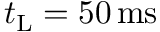Convert formula to latex. <formula><loc_0><loc_0><loc_500><loc_500>t _ { L } = 5 0 \, m s</formula> 